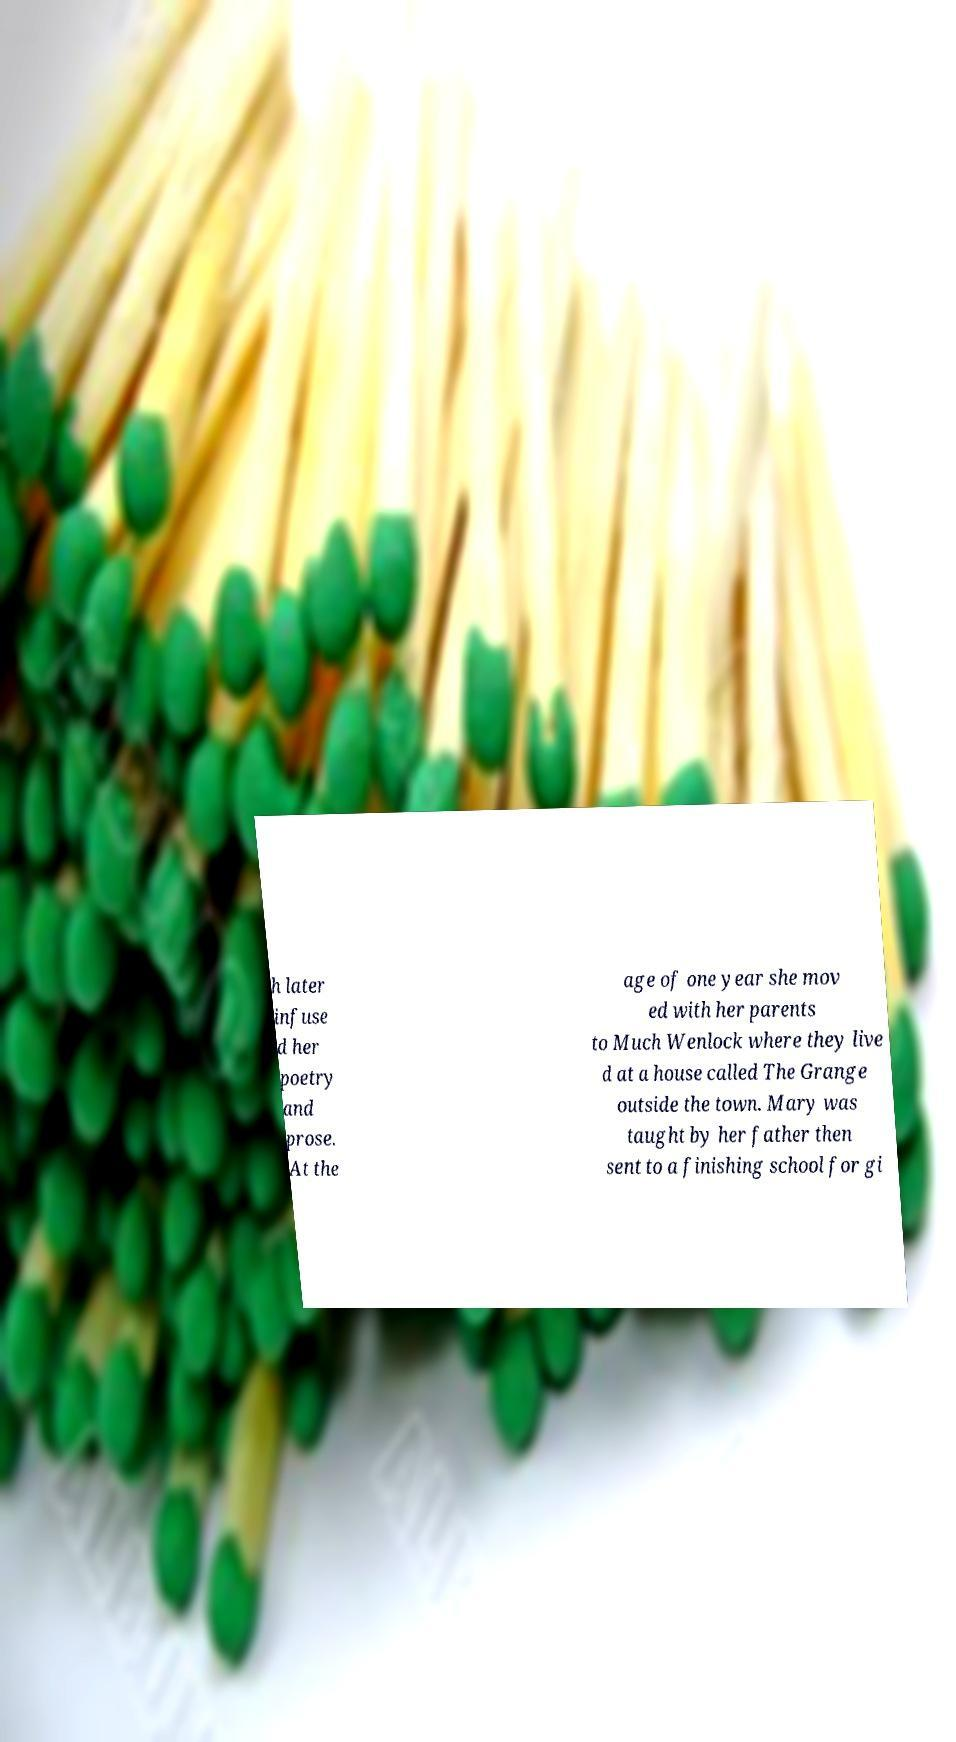Could you assist in decoding the text presented in this image and type it out clearly? h later infuse d her poetry and prose. At the age of one year she mov ed with her parents to Much Wenlock where they live d at a house called The Grange outside the town. Mary was taught by her father then sent to a finishing school for gi 